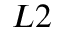Convert formula to latex. <formula><loc_0><loc_0><loc_500><loc_500>L 2</formula> 